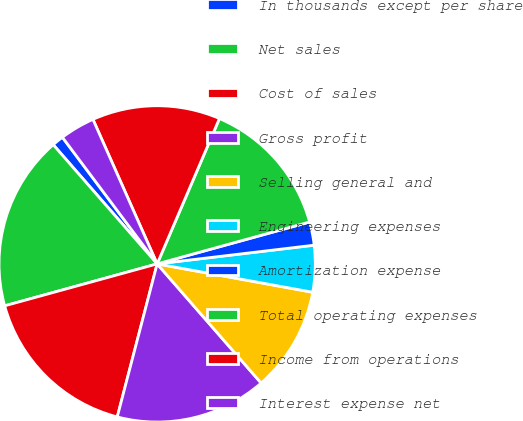<chart> <loc_0><loc_0><loc_500><loc_500><pie_chart><fcel>In thousands except per share<fcel>Net sales<fcel>Cost of sales<fcel>Gross profit<fcel>Selling general and<fcel>Engineering expenses<fcel>Amortization expense<fcel>Total operating expenses<fcel>Income from operations<fcel>Interest expense net<nl><fcel>1.19%<fcel>17.86%<fcel>16.67%<fcel>15.48%<fcel>10.71%<fcel>4.76%<fcel>2.38%<fcel>14.29%<fcel>13.1%<fcel>3.57%<nl></chart> 